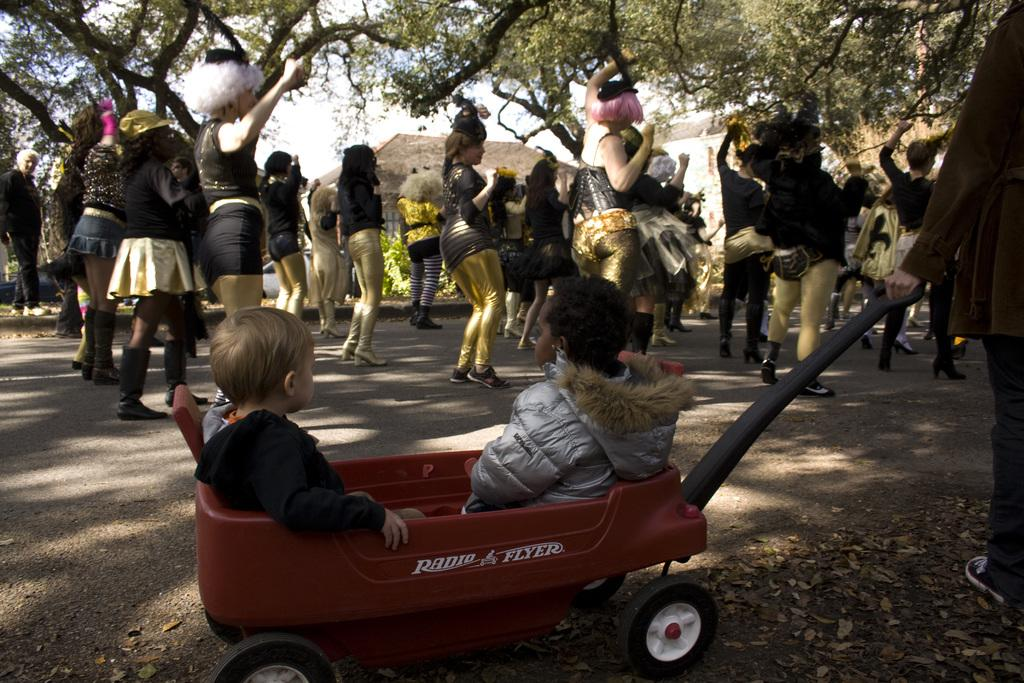What can be seen in the sky in the image? The sky is visible in the image. What type of natural elements are present in the image? There are trees in the image. What type of man-made structures can be seen in the image? There are buildings in the image. What type of transportation is present in the image? Motor vehicles are present in the image. What are the people in the image doing? There are persons standing on the road in the image. What are the children doing in the image? Children are sitting in a cart on the road in the image. What type of wool is being used to cover the eggs in the image? There are no eggs or wool present in the image. 